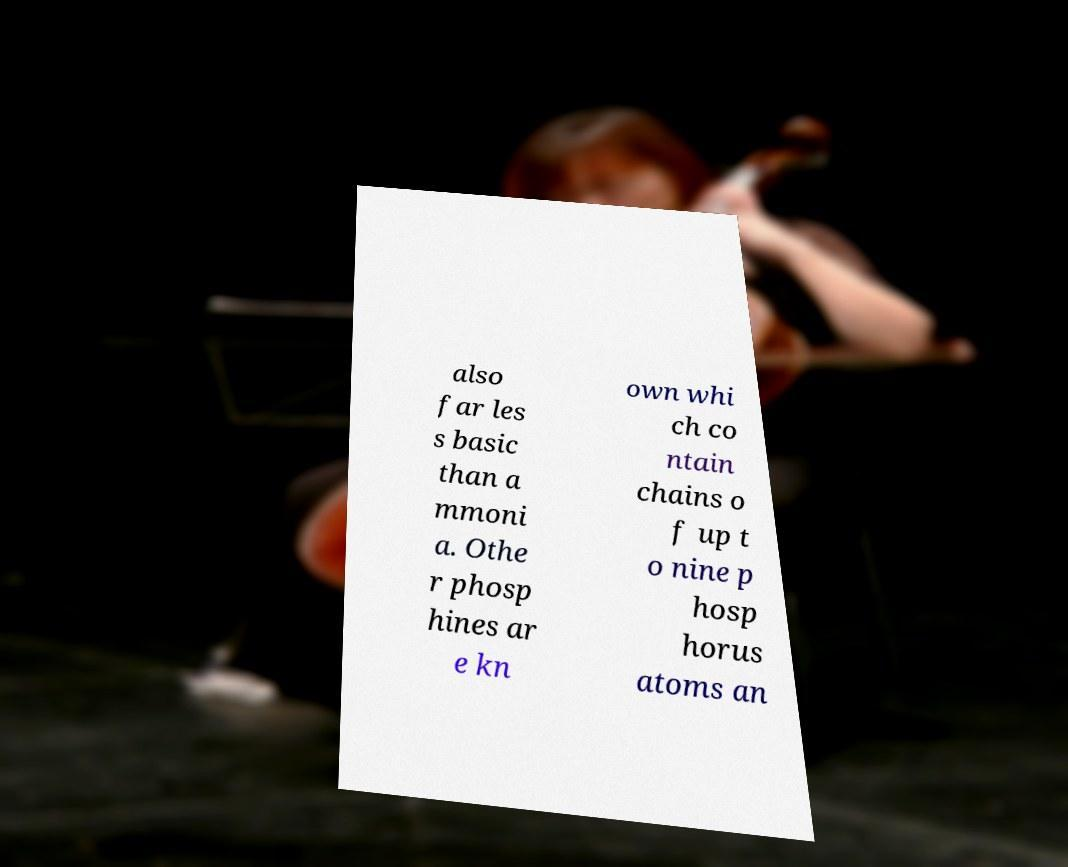Can you accurately transcribe the text from the provided image for me? also far les s basic than a mmoni a. Othe r phosp hines ar e kn own whi ch co ntain chains o f up t o nine p hosp horus atoms an 